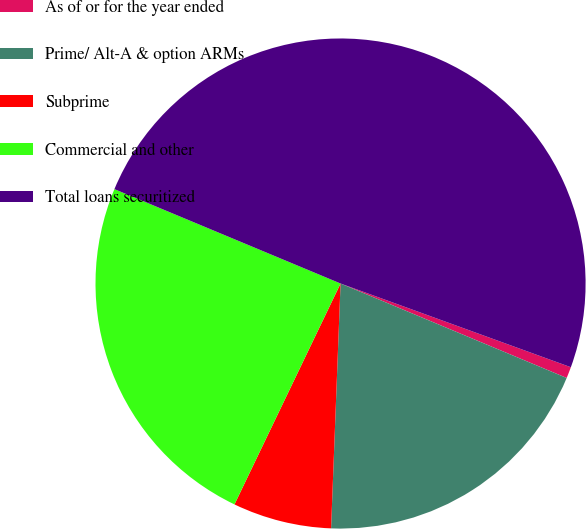Convert chart. <chart><loc_0><loc_0><loc_500><loc_500><pie_chart><fcel>As of or for the year ended<fcel>Prime/ Alt-A & option ARMs<fcel>Subprime<fcel>Commercial and other<fcel>Total loans securitized<nl><fcel>0.75%<fcel>19.32%<fcel>6.51%<fcel>24.17%<fcel>49.26%<nl></chart> 